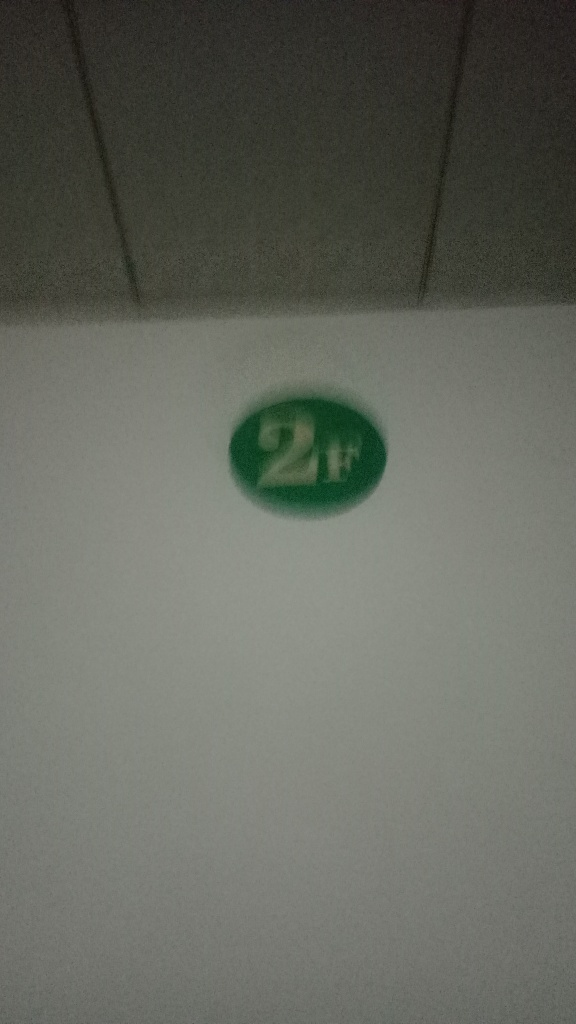What is the object in this image? The image features a round green object with the symbol '2H' on it, which appears to be affixed to a surface. The '2H' might refer to a hardness grading on a pencil indicating it is fairly hard and not very dark, or it could be labeling for a specific location or room number. However, due to the image's low quality, it's difficult to provide additional context or identify the surrounding environment. 